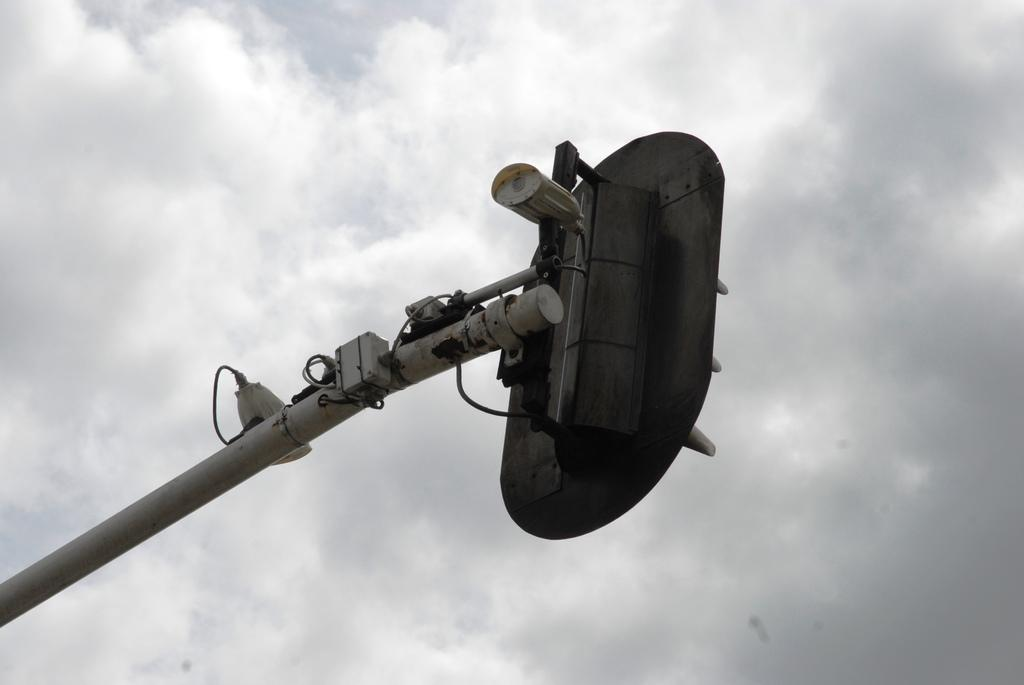What is located in the center of the image? There is a pole and a sign board in the center of the image. What can be seen in the background of the image? The sky is visible in the background of the image, and clouds are present. What type of market is being held near the pole in the image? There is no market present in the image; it only features a pole and a sign board. What rule is being enforced by the sign board in the image? The sign board in the image does not indicate any specific rule or regulation. 